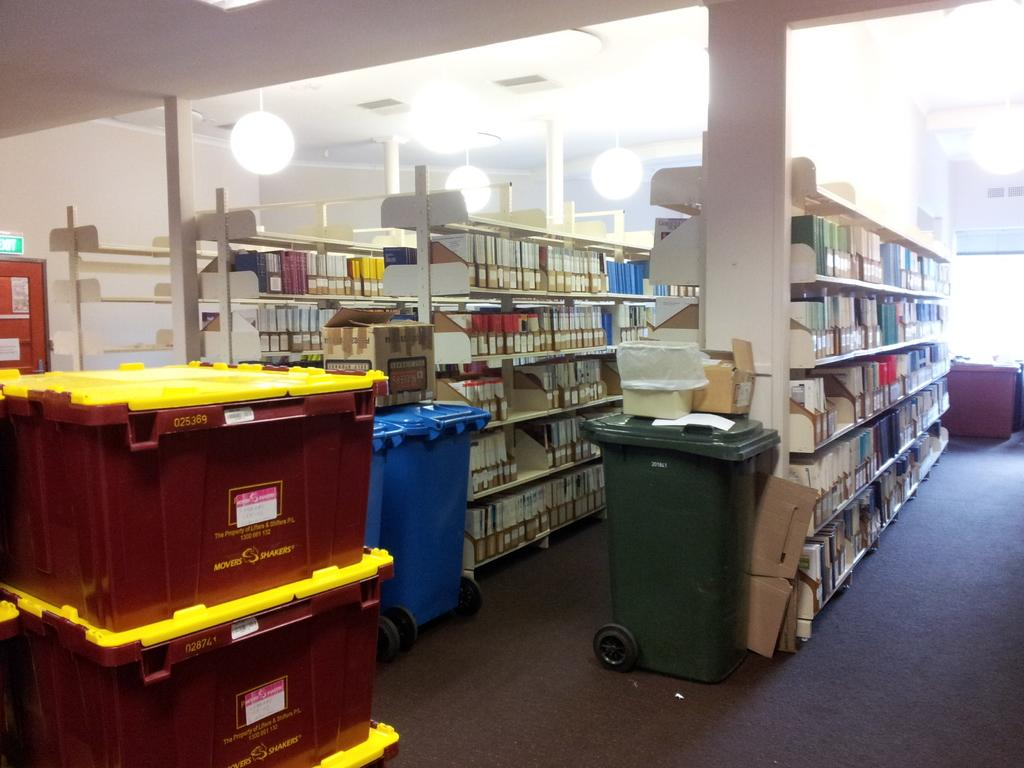<image>
Relay a brief, clear account of the picture shown. A library with bookshelves has a stack of maroon bins with yellow tops that say Movers and Shakers. 